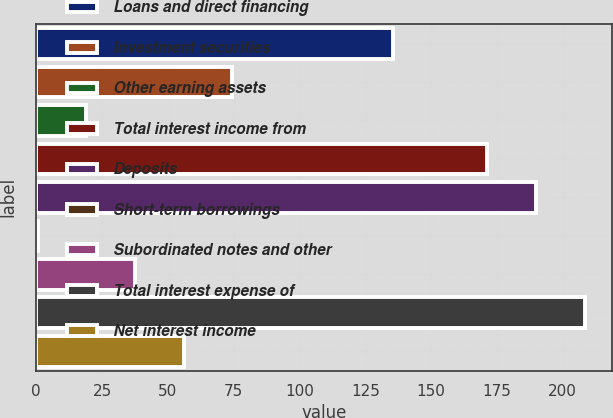Convert chart. <chart><loc_0><loc_0><loc_500><loc_500><bar_chart><fcel>Loans and direct financing<fcel>Investment securities<fcel>Other earning assets<fcel>Total interest income from<fcel>Deposits<fcel>Short-term borrowings<fcel>Subordinated notes and other<fcel>Total interest expense of<fcel>Net interest income<nl><fcel>135.6<fcel>74.54<fcel>19.01<fcel>171.4<fcel>189.91<fcel>0.5<fcel>37.52<fcel>208.42<fcel>56.03<nl></chart> 